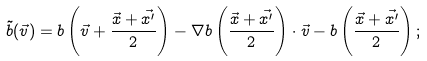<formula> <loc_0><loc_0><loc_500><loc_500>\tilde { b } ( \vec { v } ) = b \left ( \vec { v } + \frac { \vec { x } + \vec { x ^ { \prime } } } { 2 } \right ) - \nabla b \left ( \frac { \vec { x } + \vec { x ^ { \prime } } } { 2 } \right ) \cdot \vec { v } - b \left ( \frac { \vec { x } + \vec { x ^ { \prime } } } { 2 } \right ) ;</formula> 